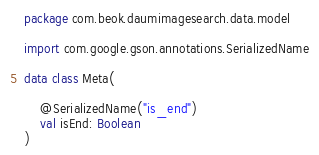Convert code to text. <code><loc_0><loc_0><loc_500><loc_500><_Kotlin_>package com.beok.daumimagesearch.data.model

import com.google.gson.annotations.SerializedName

data class Meta(

    @SerializedName("is_end")
    val isEnd: Boolean
)</code> 